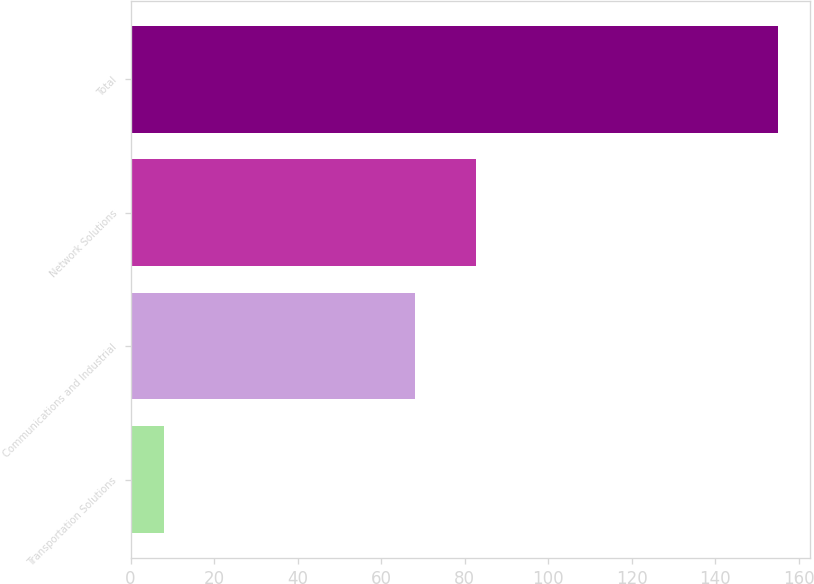Convert chart to OTSL. <chart><loc_0><loc_0><loc_500><loc_500><bar_chart><fcel>Transportation Solutions<fcel>Communications and Industrial<fcel>Network Solutions<fcel>Total<nl><fcel>8<fcel>68<fcel>82.7<fcel>155<nl></chart> 